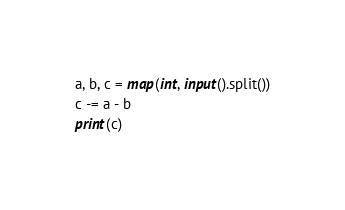Convert code to text. <code><loc_0><loc_0><loc_500><loc_500><_Python_>a, b, c = map(int, input().split())
c -= a - b
print(c)</code> 